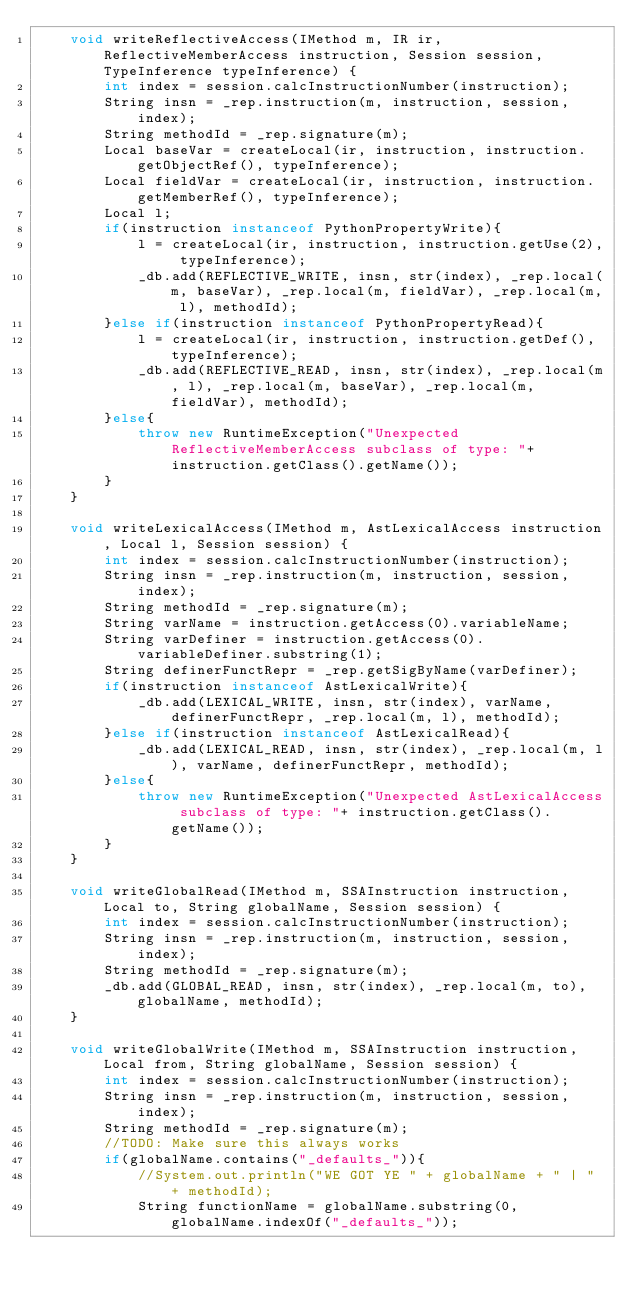<code> <loc_0><loc_0><loc_500><loc_500><_Java_>    void writeReflectiveAccess(IMethod m, IR ir, ReflectiveMemberAccess instruction, Session session, TypeInference typeInference) {
        int index = session.calcInstructionNumber(instruction);
        String insn = _rep.instruction(m, instruction, session, index);
        String methodId = _rep.signature(m);
        Local baseVar = createLocal(ir, instruction, instruction.getObjectRef(), typeInference);
        Local fieldVar = createLocal(ir, instruction, instruction.getMemberRef(), typeInference);
        Local l;
        if(instruction instanceof PythonPropertyWrite){
            l = createLocal(ir, instruction, instruction.getUse(2), typeInference);
            _db.add(REFLECTIVE_WRITE, insn, str(index), _rep.local(m, baseVar), _rep.local(m, fieldVar), _rep.local(m, l), methodId);
        }else if(instruction instanceof PythonPropertyRead){
            l = createLocal(ir, instruction, instruction.getDef(), typeInference);
            _db.add(REFLECTIVE_READ, insn, str(index), _rep.local(m, l), _rep.local(m, baseVar), _rep.local(m, fieldVar), methodId);
        }else{
            throw new RuntimeException("Unexpected ReflectiveMemberAccess subclass of type: "+ instruction.getClass().getName());
        }
    }

    void writeLexicalAccess(IMethod m, AstLexicalAccess instruction, Local l, Session session) {
        int index = session.calcInstructionNumber(instruction);
        String insn = _rep.instruction(m, instruction, session, index);
        String methodId = _rep.signature(m);
        String varName = instruction.getAccess(0).variableName;
        String varDefiner = instruction.getAccess(0).variableDefiner.substring(1);
        String definerFunctRepr = _rep.getSigByName(varDefiner);
        if(instruction instanceof AstLexicalWrite){
            _db.add(LEXICAL_WRITE, insn, str(index), varName, definerFunctRepr, _rep.local(m, l), methodId);
        }else if(instruction instanceof AstLexicalRead){
            _db.add(LEXICAL_READ, insn, str(index), _rep.local(m, l), varName, definerFunctRepr, methodId);
        }else{
            throw new RuntimeException("Unexpected AstLexicalAccess subclass of type: "+ instruction.getClass().getName());
        }
    }

    void writeGlobalRead(IMethod m, SSAInstruction instruction, Local to, String globalName, Session session) {
        int index = session.calcInstructionNumber(instruction);
        String insn = _rep.instruction(m, instruction, session, index);
        String methodId = _rep.signature(m);
        _db.add(GLOBAL_READ, insn, str(index), _rep.local(m, to), globalName, methodId);
    }

    void writeGlobalWrite(IMethod m, SSAInstruction instruction, Local from, String globalName, Session session) {
        int index = session.calcInstructionNumber(instruction);
        String insn = _rep.instruction(m, instruction, session, index);
        String methodId = _rep.signature(m);
        //TODO: Make sure this always works
        if(globalName.contains("_defaults_")){
            //System.out.println("WE GOT YE " + globalName + " | " + methodId);
            String functionName = globalName.substring(0, globalName.indexOf("_defaults_"));</code> 